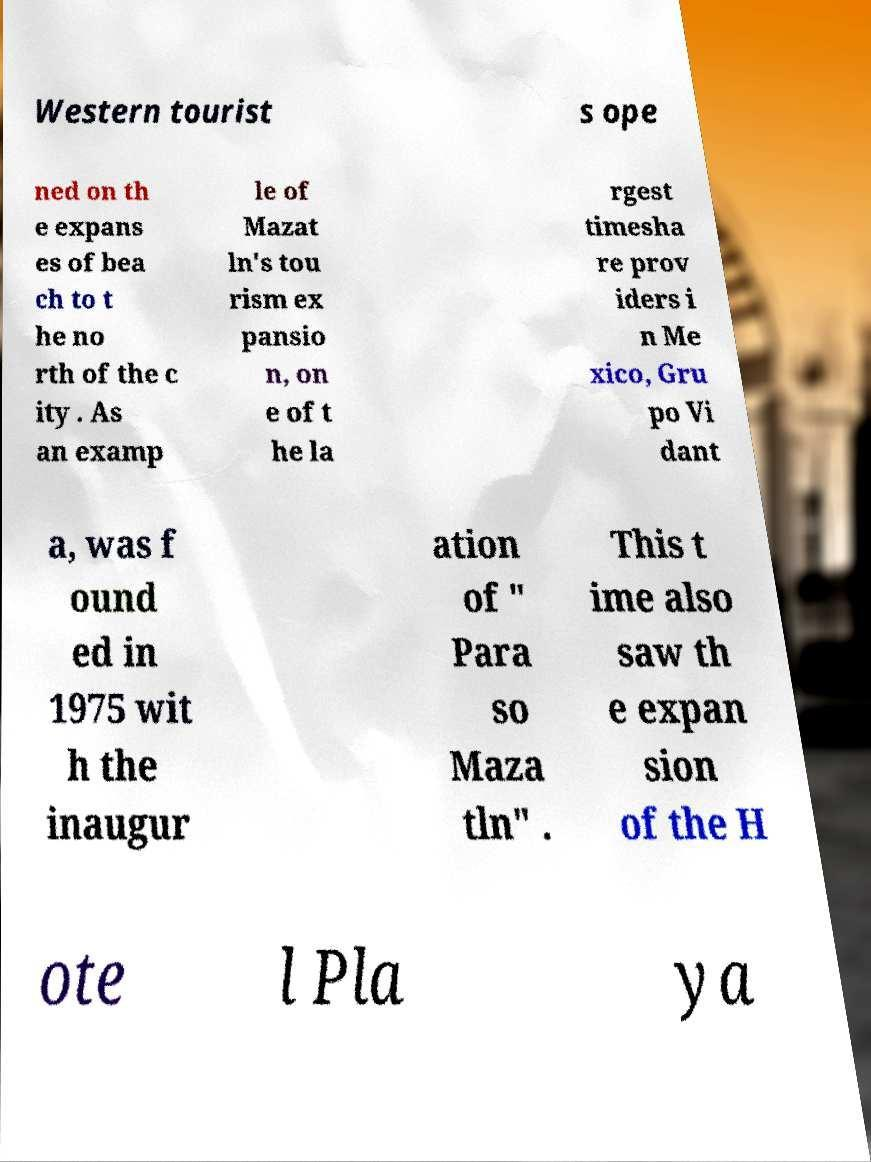Please identify and transcribe the text found in this image. Western tourist s ope ned on th e expans es of bea ch to t he no rth of the c ity . As an examp le of Mazat ln's tou rism ex pansio n, on e of t he la rgest timesha re prov iders i n Me xico, Gru po Vi dant a, was f ound ed in 1975 wit h the inaugur ation of " Para so Maza tln" . This t ime also saw th e expan sion of the H ote l Pla ya 